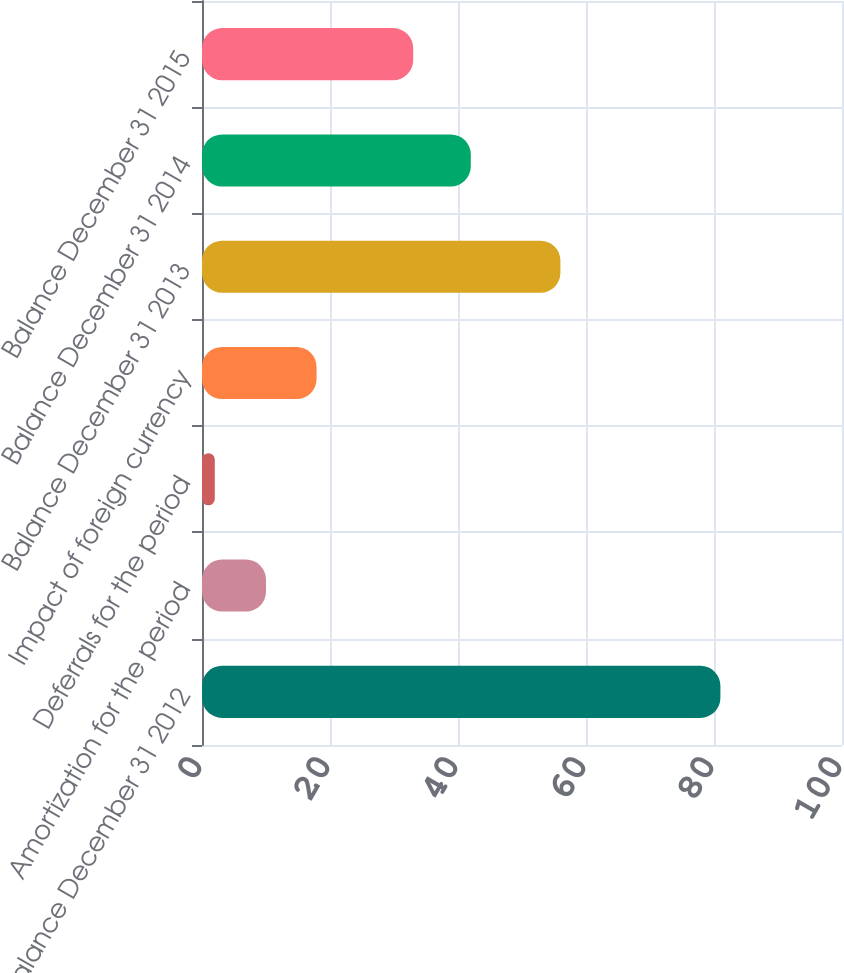<chart> <loc_0><loc_0><loc_500><loc_500><bar_chart><fcel>Balance December 31 2012<fcel>Amortization for the period<fcel>Deferrals for the period<fcel>Impact of foreign currency<fcel>Balance December 31 2013<fcel>Balance December 31 2014<fcel>Balance December 31 2015<nl><fcel>81<fcel>10<fcel>2<fcel>17.9<fcel>56<fcel>42<fcel>33<nl></chart> 